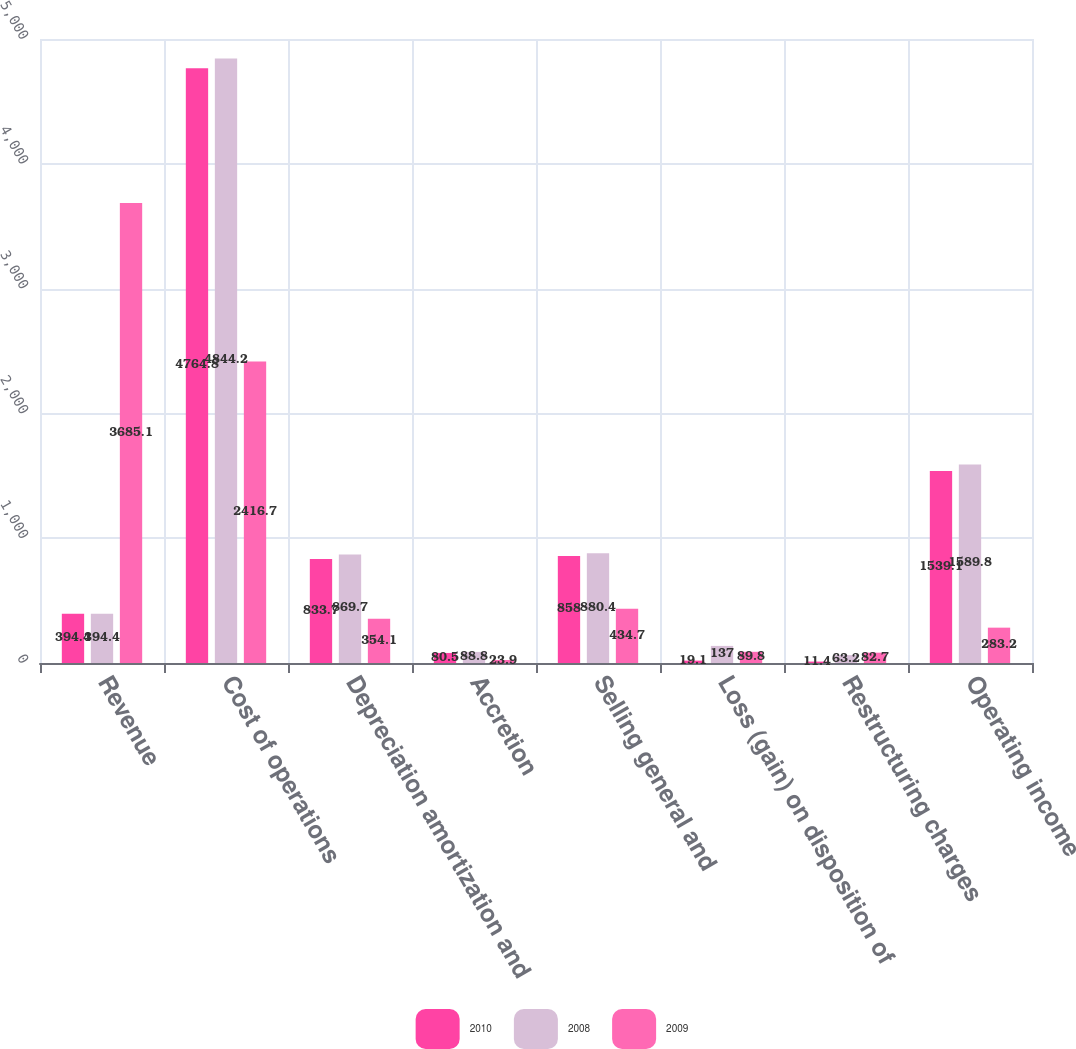Convert chart. <chart><loc_0><loc_0><loc_500><loc_500><stacked_bar_chart><ecel><fcel>Revenue<fcel>Cost of operations<fcel>Depreciation amortization and<fcel>Accretion<fcel>Selling general and<fcel>Loss (gain) on disposition of<fcel>Restructuring charges<fcel>Operating income<nl><fcel>2010<fcel>394.4<fcel>4764.8<fcel>833.7<fcel>80.5<fcel>858<fcel>19.1<fcel>11.4<fcel>1539.1<nl><fcel>2008<fcel>394.4<fcel>4844.2<fcel>869.7<fcel>88.8<fcel>880.4<fcel>137<fcel>63.2<fcel>1589.8<nl><fcel>2009<fcel>3685.1<fcel>2416.7<fcel>354.1<fcel>23.9<fcel>434.7<fcel>89.8<fcel>82.7<fcel>283.2<nl></chart> 